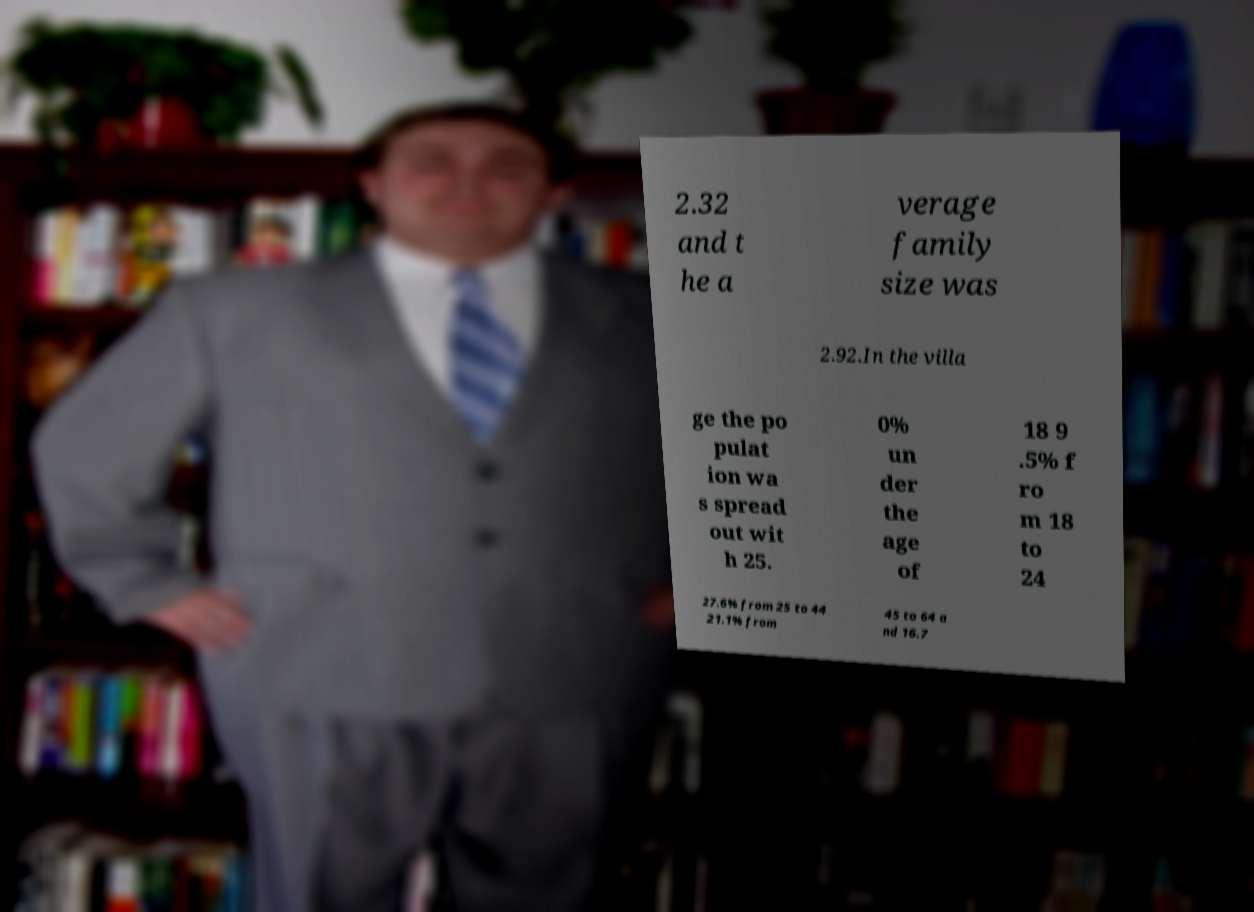Can you accurately transcribe the text from the provided image for me? 2.32 and t he a verage family size was 2.92.In the villa ge the po pulat ion wa s spread out wit h 25. 0% un der the age of 18 9 .5% f ro m 18 to 24 27.6% from 25 to 44 21.1% from 45 to 64 a nd 16.7 